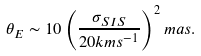Convert formula to latex. <formula><loc_0><loc_0><loc_500><loc_500>\theta _ { E } \sim 1 0 \left ( \frac { \sigma _ { S I S } } { 2 0 k m s ^ { - 1 } } \right ) ^ { 2 } m a s .</formula> 